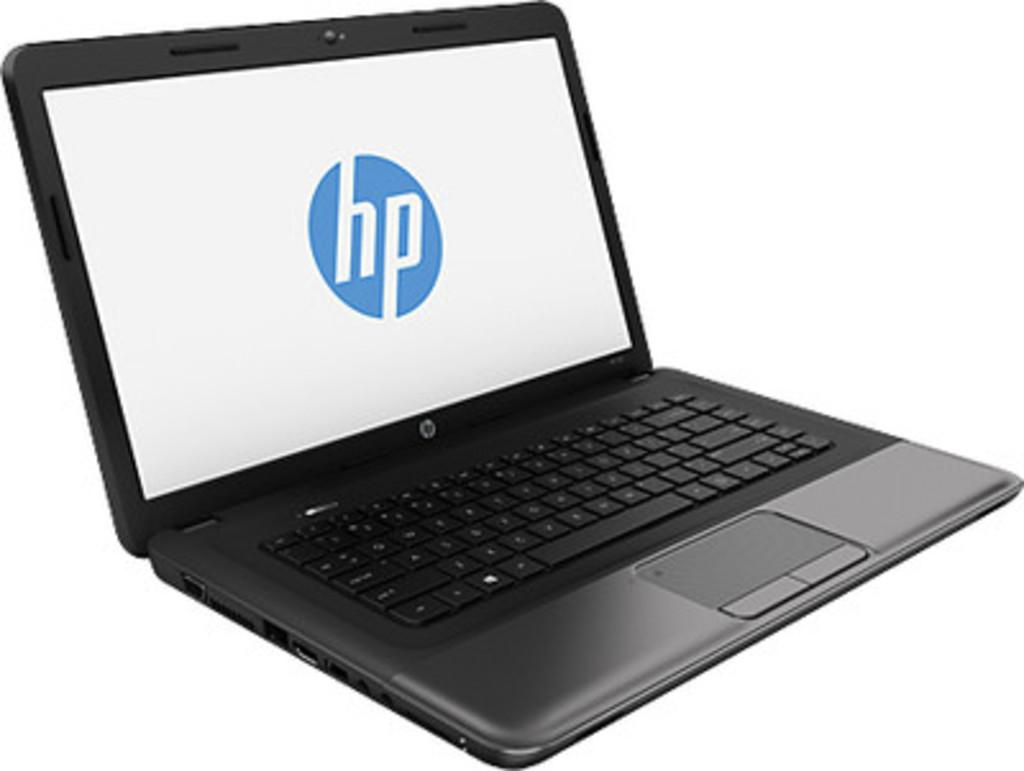<image>
Create a compact narrative representing the image presented. The black laptop shown is made by the company hp. 